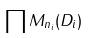Convert formula to latex. <formula><loc_0><loc_0><loc_500><loc_500>\prod M _ { n _ { i } } ( D _ { i } )</formula> 